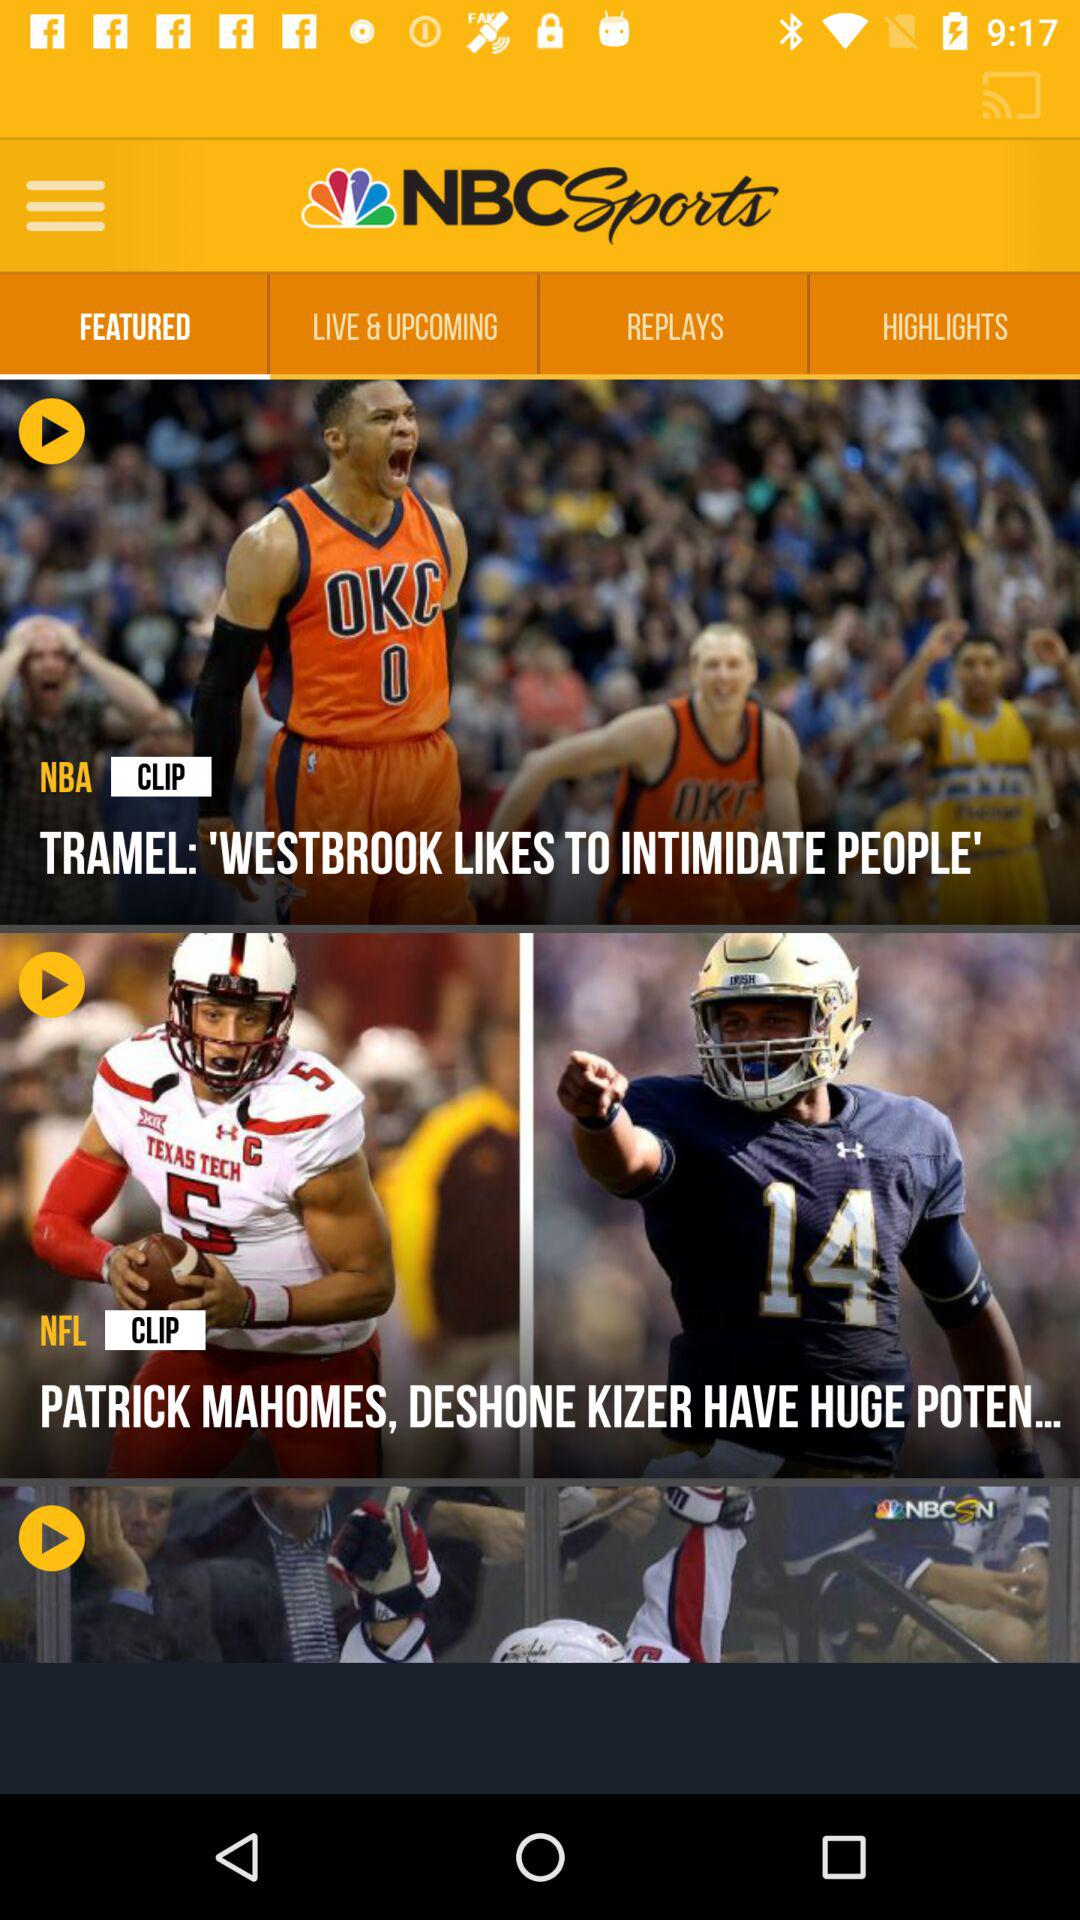What is the name of the application? The name of the application is "NBC Sports". 